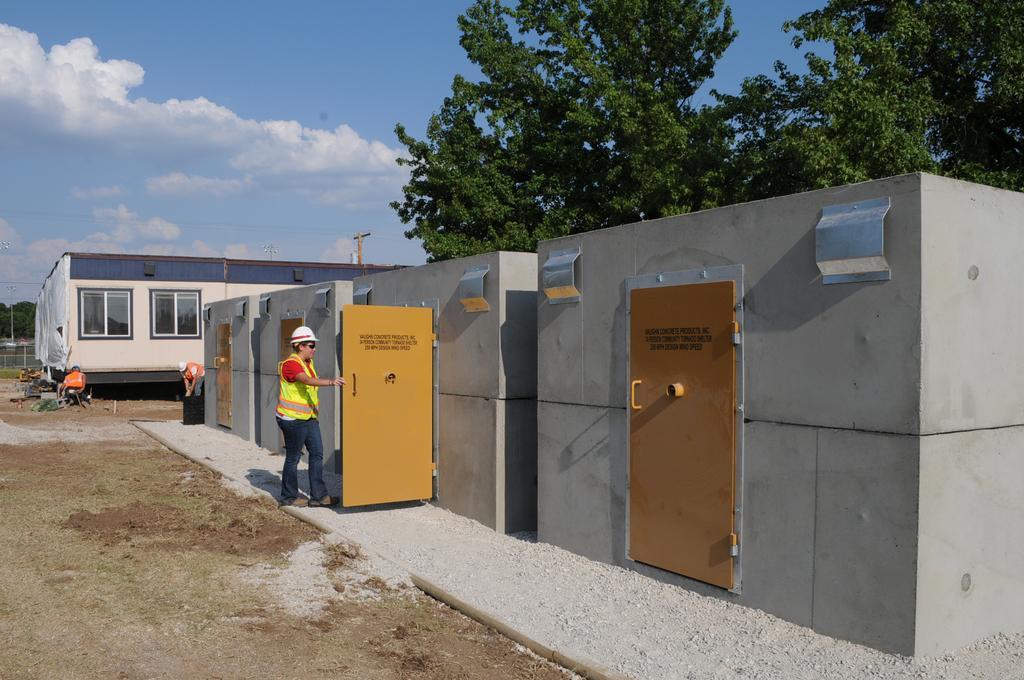Could you give a brief overview of what you see in this image? In the image there is a man in safety dress and helmet going in to a room, behind there are trees with a building beside it and above its sky with clouds. 